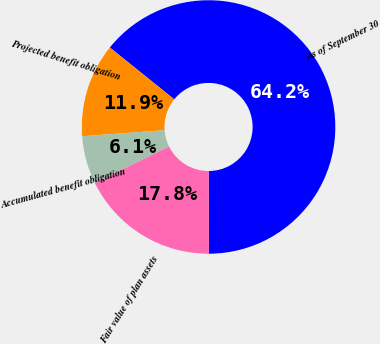<chart> <loc_0><loc_0><loc_500><loc_500><pie_chart><fcel>As of September 30<fcel>Projected benefit obligation<fcel>Accumulated benefit obligation<fcel>Fair value of plan assets<nl><fcel>64.16%<fcel>11.95%<fcel>6.14%<fcel>17.75%<nl></chart> 